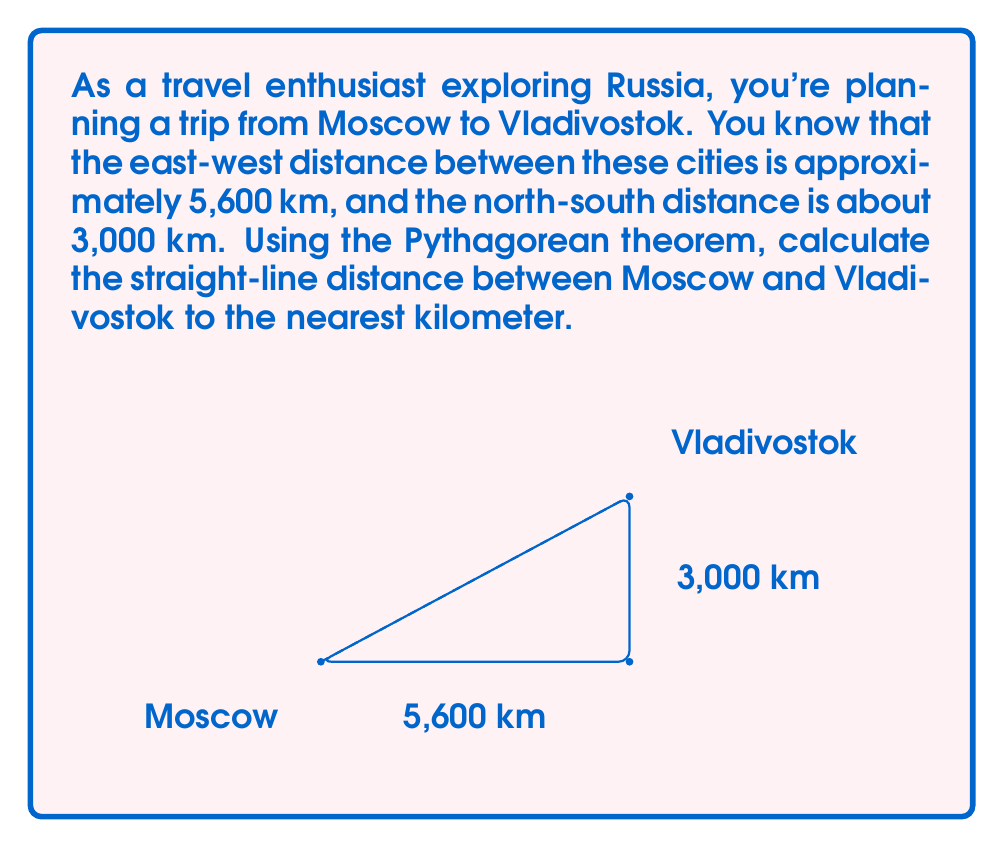Show me your answer to this math problem. Let's approach this problem step-by-step using the Pythagorean theorem:

1) The Pythagorean theorem states that in a right-angled triangle, the square of the length of the hypotenuse (c) is equal to the sum of squares of the other two sides (a and b). 

   $$a^2 + b^2 = c^2$$

2) In our case:
   - a = east-west distance = 5,600 km
   - b = north-south distance = 3,000 km
   - c = straight-line distance (what we're solving for)

3) Let's substitute these values into the formula:

   $$(5600)^2 + (3000)^2 = c^2$$

4) Now, let's calculate:

   $$31,360,000 + 9,000,000 = c^2$$
   $$40,360,000 = c^2$$

5) To find c, we need to take the square root of both sides:

   $$c = \sqrt{40,360,000}$$

6) Using a calculator:

   $$c \approx 6,353.75 \text{ km}$$

7) Rounding to the nearest kilometer:

   $$c \approx 6,354 \text{ km}$$

Thus, the straight-line distance between Moscow and Vladivostok is approximately 6,354 km.
Answer: 6,354 km 